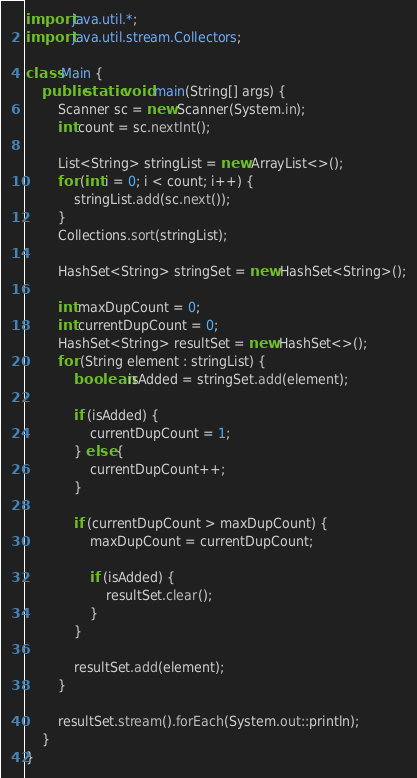<code> <loc_0><loc_0><loc_500><loc_500><_Java_>import java.util.*;
import java.util.stream.Collectors;

class Main {
    public static void main(String[] args) {
        Scanner sc = new Scanner(System.in);
        int count = sc.nextInt();

        List<String> stringList = new ArrayList<>();
        for (int i = 0; i < count; i++) {
            stringList.add(sc.next());
        }
        Collections.sort(stringList);

        HashSet<String> stringSet = new HashSet<String>();

        int maxDupCount = 0;
        int currentDupCount = 0;
        HashSet<String> resultSet = new HashSet<>();
        for (String element : stringList) {
            boolean isAdded = stringSet.add(element);

            if (isAdded) {
                currentDupCount = 1;
            } else {
                currentDupCount++;
            }

            if (currentDupCount > maxDupCount) {
                maxDupCount = currentDupCount;

                if (isAdded) {
                    resultSet.clear();
                }
            }

            resultSet.add(element);
        }

        resultSet.stream().forEach(System.out::println);
    }
}
</code> 